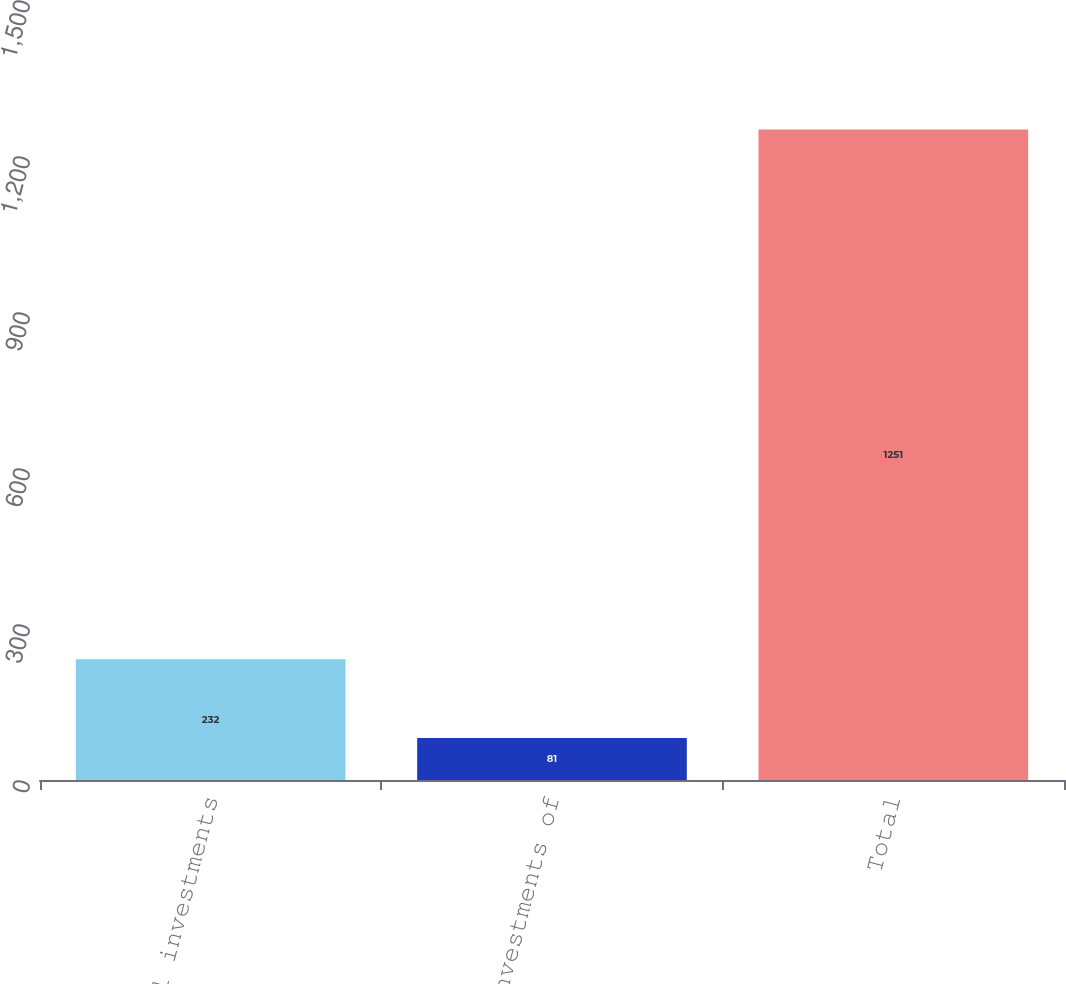Convert chart to OTSL. <chart><loc_0><loc_0><loc_500><loc_500><bar_chart><fcel>Total investments<fcel>Total investments of<fcel>Total<nl><fcel>232<fcel>81<fcel>1251<nl></chart> 